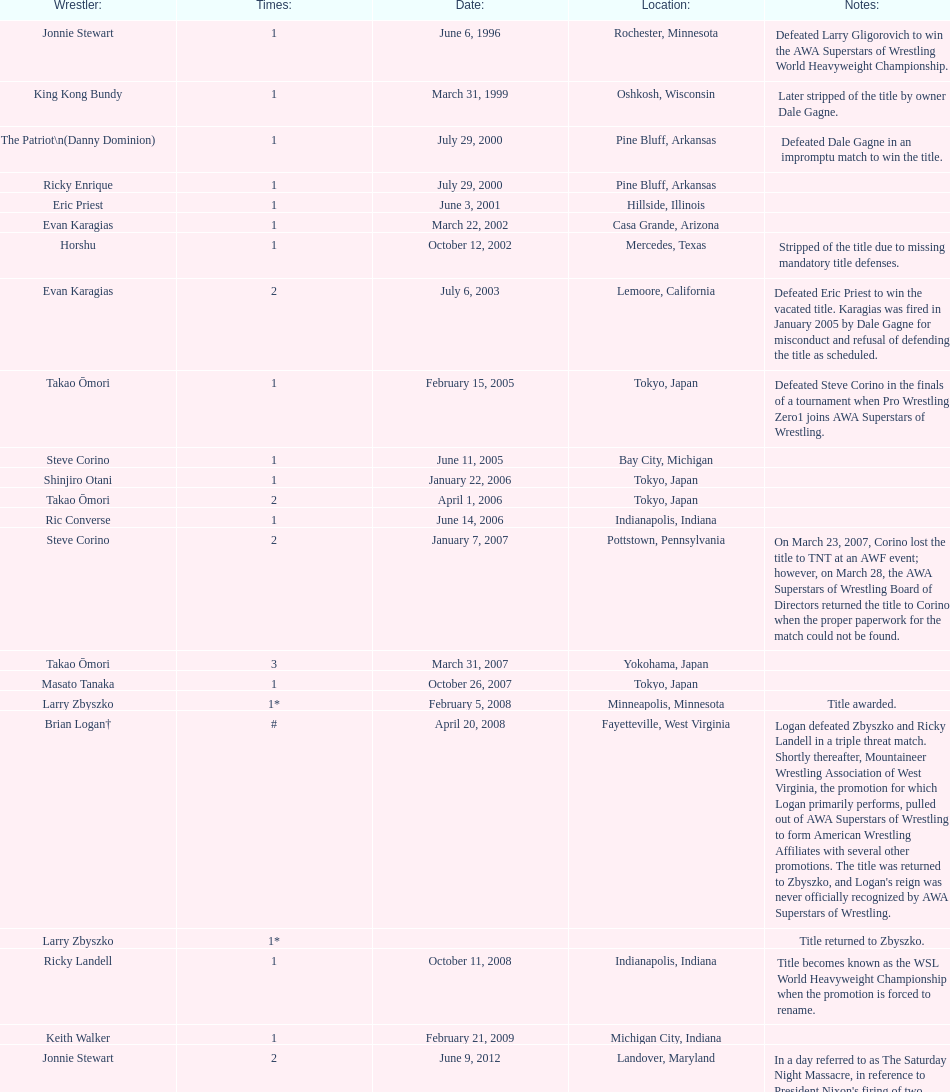Who is the exclusive wsl trophy holder from texas? Horshu. 